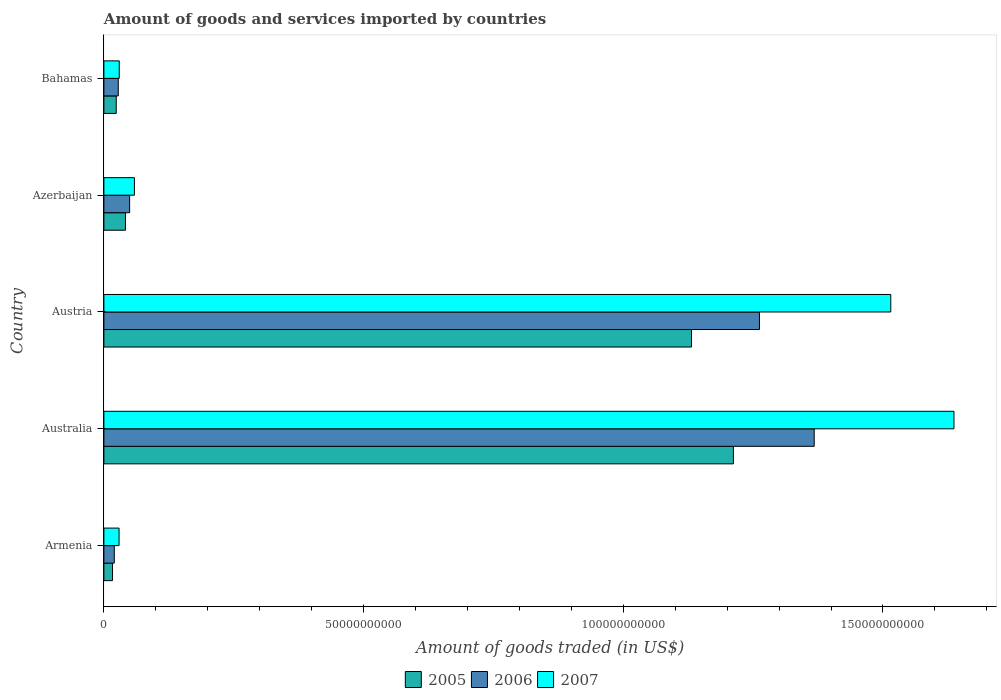How many different coloured bars are there?
Your answer should be compact. 3. Are the number of bars per tick equal to the number of legend labels?
Your response must be concise. Yes. What is the label of the 5th group of bars from the top?
Provide a short and direct response. Armenia. What is the total amount of goods and services imported in 2005 in Austria?
Ensure brevity in your answer.  1.13e+11. Across all countries, what is the maximum total amount of goods and services imported in 2005?
Your response must be concise. 1.21e+11. Across all countries, what is the minimum total amount of goods and services imported in 2005?
Your response must be concise. 1.66e+09. In which country was the total amount of goods and services imported in 2006 maximum?
Your answer should be compact. Australia. In which country was the total amount of goods and services imported in 2007 minimum?
Your answer should be compact. Armenia. What is the total total amount of goods and services imported in 2006 in the graph?
Offer a very short reply. 2.73e+11. What is the difference between the total amount of goods and services imported in 2005 in Australia and that in Azerbaijan?
Offer a terse response. 1.17e+11. What is the difference between the total amount of goods and services imported in 2005 in Bahamas and the total amount of goods and services imported in 2006 in Azerbaijan?
Your answer should be very brief. -2.58e+09. What is the average total amount of goods and services imported in 2005 per country?
Make the answer very short. 4.85e+1. What is the difference between the total amount of goods and services imported in 2005 and total amount of goods and services imported in 2007 in Australia?
Ensure brevity in your answer.  -4.25e+1. In how many countries, is the total amount of goods and services imported in 2007 greater than 110000000000 US$?
Offer a terse response. 2. What is the ratio of the total amount of goods and services imported in 2005 in Armenia to that in Austria?
Offer a terse response. 0.01. Is the difference between the total amount of goods and services imported in 2005 in Armenia and Australia greater than the difference between the total amount of goods and services imported in 2007 in Armenia and Australia?
Offer a terse response. Yes. What is the difference between the highest and the second highest total amount of goods and services imported in 2005?
Ensure brevity in your answer.  8.06e+09. What is the difference between the highest and the lowest total amount of goods and services imported in 2005?
Keep it short and to the point. 1.20e+11. In how many countries, is the total amount of goods and services imported in 2006 greater than the average total amount of goods and services imported in 2006 taken over all countries?
Give a very brief answer. 2. Is the sum of the total amount of goods and services imported in 2006 in Armenia and Australia greater than the maximum total amount of goods and services imported in 2007 across all countries?
Ensure brevity in your answer.  No. What does the 1st bar from the top in Bahamas represents?
Offer a very short reply. 2007. Is it the case that in every country, the sum of the total amount of goods and services imported in 2005 and total amount of goods and services imported in 2006 is greater than the total amount of goods and services imported in 2007?
Offer a terse response. Yes. How many bars are there?
Your response must be concise. 15. Are all the bars in the graph horizontal?
Ensure brevity in your answer.  Yes. What is the difference between two consecutive major ticks on the X-axis?
Offer a terse response. 5.00e+1. Are the values on the major ticks of X-axis written in scientific E-notation?
Provide a succinct answer. No. How are the legend labels stacked?
Give a very brief answer. Horizontal. What is the title of the graph?
Provide a succinct answer. Amount of goods and services imported by countries. Does "1999" appear as one of the legend labels in the graph?
Keep it short and to the point. No. What is the label or title of the X-axis?
Your response must be concise. Amount of goods traded (in US$). What is the label or title of the Y-axis?
Your answer should be compact. Country. What is the Amount of goods traded (in US$) of 2005 in Armenia?
Ensure brevity in your answer.  1.66e+09. What is the Amount of goods traded (in US$) in 2006 in Armenia?
Offer a terse response. 2.00e+09. What is the Amount of goods traded (in US$) in 2007 in Armenia?
Provide a succinct answer. 2.92e+09. What is the Amount of goods traded (in US$) in 2005 in Australia?
Give a very brief answer. 1.21e+11. What is the Amount of goods traded (in US$) of 2006 in Australia?
Offer a terse response. 1.37e+11. What is the Amount of goods traded (in US$) of 2007 in Australia?
Provide a succinct answer. 1.64e+11. What is the Amount of goods traded (in US$) of 2005 in Austria?
Provide a succinct answer. 1.13e+11. What is the Amount of goods traded (in US$) of 2006 in Austria?
Offer a terse response. 1.26e+11. What is the Amount of goods traded (in US$) of 2007 in Austria?
Give a very brief answer. 1.52e+11. What is the Amount of goods traded (in US$) of 2005 in Azerbaijan?
Ensure brevity in your answer.  4.15e+09. What is the Amount of goods traded (in US$) in 2006 in Azerbaijan?
Your answer should be very brief. 4.95e+09. What is the Amount of goods traded (in US$) in 2007 in Azerbaijan?
Provide a succinct answer. 5.88e+09. What is the Amount of goods traded (in US$) of 2005 in Bahamas?
Give a very brief answer. 2.38e+09. What is the Amount of goods traded (in US$) of 2006 in Bahamas?
Your answer should be compact. 2.77e+09. What is the Amount of goods traded (in US$) of 2007 in Bahamas?
Provide a short and direct response. 2.96e+09. Across all countries, what is the maximum Amount of goods traded (in US$) in 2005?
Offer a terse response. 1.21e+11. Across all countries, what is the maximum Amount of goods traded (in US$) of 2006?
Provide a succinct answer. 1.37e+11. Across all countries, what is the maximum Amount of goods traded (in US$) of 2007?
Your answer should be very brief. 1.64e+11. Across all countries, what is the minimum Amount of goods traded (in US$) of 2005?
Your answer should be compact. 1.66e+09. Across all countries, what is the minimum Amount of goods traded (in US$) of 2006?
Your response must be concise. 2.00e+09. Across all countries, what is the minimum Amount of goods traded (in US$) of 2007?
Offer a very short reply. 2.92e+09. What is the total Amount of goods traded (in US$) in 2005 in the graph?
Your answer should be compact. 2.43e+11. What is the total Amount of goods traded (in US$) of 2006 in the graph?
Give a very brief answer. 2.73e+11. What is the total Amount of goods traded (in US$) of 2007 in the graph?
Ensure brevity in your answer.  3.27e+11. What is the difference between the Amount of goods traded (in US$) in 2005 in Armenia and that in Australia?
Your answer should be compact. -1.20e+11. What is the difference between the Amount of goods traded (in US$) of 2006 in Armenia and that in Australia?
Offer a very short reply. -1.35e+11. What is the difference between the Amount of goods traded (in US$) of 2007 in Armenia and that in Australia?
Provide a succinct answer. -1.61e+11. What is the difference between the Amount of goods traded (in US$) in 2005 in Armenia and that in Austria?
Your response must be concise. -1.11e+11. What is the difference between the Amount of goods traded (in US$) of 2006 in Armenia and that in Austria?
Your answer should be very brief. -1.24e+11. What is the difference between the Amount of goods traded (in US$) of 2007 in Armenia and that in Austria?
Keep it short and to the point. -1.49e+11. What is the difference between the Amount of goods traded (in US$) of 2005 in Armenia and that in Azerbaijan?
Provide a short and direct response. -2.49e+09. What is the difference between the Amount of goods traded (in US$) in 2006 in Armenia and that in Azerbaijan?
Ensure brevity in your answer.  -2.95e+09. What is the difference between the Amount of goods traded (in US$) in 2007 in Armenia and that in Azerbaijan?
Your answer should be compact. -2.96e+09. What is the difference between the Amount of goods traded (in US$) in 2005 in Armenia and that in Bahamas?
Your answer should be compact. -7.14e+08. What is the difference between the Amount of goods traded (in US$) in 2006 in Armenia and that in Bahamas?
Make the answer very short. -7.67e+08. What is the difference between the Amount of goods traded (in US$) in 2007 in Armenia and that in Bahamas?
Your answer should be very brief. -3.58e+07. What is the difference between the Amount of goods traded (in US$) in 2005 in Australia and that in Austria?
Provide a short and direct response. 8.06e+09. What is the difference between the Amount of goods traded (in US$) in 2006 in Australia and that in Austria?
Your answer should be compact. 1.05e+1. What is the difference between the Amount of goods traded (in US$) in 2007 in Australia and that in Austria?
Your answer should be very brief. 1.22e+1. What is the difference between the Amount of goods traded (in US$) in 2005 in Australia and that in Azerbaijan?
Your answer should be very brief. 1.17e+11. What is the difference between the Amount of goods traded (in US$) of 2006 in Australia and that in Azerbaijan?
Offer a terse response. 1.32e+11. What is the difference between the Amount of goods traded (in US$) in 2007 in Australia and that in Azerbaijan?
Offer a terse response. 1.58e+11. What is the difference between the Amount of goods traded (in US$) of 2005 in Australia and that in Bahamas?
Make the answer very short. 1.19e+11. What is the difference between the Amount of goods traded (in US$) in 2006 in Australia and that in Bahamas?
Offer a very short reply. 1.34e+11. What is the difference between the Amount of goods traded (in US$) of 2007 in Australia and that in Bahamas?
Your answer should be very brief. 1.61e+11. What is the difference between the Amount of goods traded (in US$) of 2005 in Austria and that in Azerbaijan?
Provide a short and direct response. 1.09e+11. What is the difference between the Amount of goods traded (in US$) in 2006 in Austria and that in Azerbaijan?
Ensure brevity in your answer.  1.21e+11. What is the difference between the Amount of goods traded (in US$) of 2007 in Austria and that in Azerbaijan?
Your answer should be very brief. 1.46e+11. What is the difference between the Amount of goods traded (in US$) of 2005 in Austria and that in Bahamas?
Offer a very short reply. 1.11e+11. What is the difference between the Amount of goods traded (in US$) of 2006 in Austria and that in Bahamas?
Your response must be concise. 1.23e+11. What is the difference between the Amount of goods traded (in US$) of 2007 in Austria and that in Bahamas?
Offer a terse response. 1.49e+11. What is the difference between the Amount of goods traded (in US$) of 2005 in Azerbaijan and that in Bahamas?
Ensure brevity in your answer.  1.77e+09. What is the difference between the Amount of goods traded (in US$) of 2006 in Azerbaijan and that in Bahamas?
Provide a succinct answer. 2.19e+09. What is the difference between the Amount of goods traded (in US$) of 2007 in Azerbaijan and that in Bahamas?
Make the answer very short. 2.92e+09. What is the difference between the Amount of goods traded (in US$) in 2005 in Armenia and the Amount of goods traded (in US$) in 2006 in Australia?
Make the answer very short. -1.35e+11. What is the difference between the Amount of goods traded (in US$) in 2005 in Armenia and the Amount of goods traded (in US$) in 2007 in Australia?
Your answer should be very brief. -1.62e+11. What is the difference between the Amount of goods traded (in US$) in 2006 in Armenia and the Amount of goods traded (in US$) in 2007 in Australia?
Your answer should be very brief. -1.62e+11. What is the difference between the Amount of goods traded (in US$) of 2005 in Armenia and the Amount of goods traded (in US$) of 2006 in Austria?
Your answer should be very brief. -1.25e+11. What is the difference between the Amount of goods traded (in US$) of 2005 in Armenia and the Amount of goods traded (in US$) of 2007 in Austria?
Ensure brevity in your answer.  -1.50e+11. What is the difference between the Amount of goods traded (in US$) in 2006 in Armenia and the Amount of goods traded (in US$) in 2007 in Austria?
Offer a very short reply. -1.50e+11. What is the difference between the Amount of goods traded (in US$) of 2005 in Armenia and the Amount of goods traded (in US$) of 2006 in Azerbaijan?
Give a very brief answer. -3.29e+09. What is the difference between the Amount of goods traded (in US$) in 2005 in Armenia and the Amount of goods traded (in US$) in 2007 in Azerbaijan?
Your response must be concise. -4.21e+09. What is the difference between the Amount of goods traded (in US$) in 2006 in Armenia and the Amount of goods traded (in US$) in 2007 in Azerbaijan?
Your answer should be compact. -3.88e+09. What is the difference between the Amount of goods traded (in US$) in 2005 in Armenia and the Amount of goods traded (in US$) in 2006 in Bahamas?
Ensure brevity in your answer.  -1.10e+09. What is the difference between the Amount of goods traded (in US$) of 2005 in Armenia and the Amount of goods traded (in US$) of 2007 in Bahamas?
Keep it short and to the point. -1.29e+09. What is the difference between the Amount of goods traded (in US$) of 2006 in Armenia and the Amount of goods traded (in US$) of 2007 in Bahamas?
Keep it short and to the point. -9.57e+08. What is the difference between the Amount of goods traded (in US$) in 2005 in Australia and the Amount of goods traded (in US$) in 2006 in Austria?
Keep it short and to the point. -5.01e+09. What is the difference between the Amount of goods traded (in US$) of 2005 in Australia and the Amount of goods traded (in US$) of 2007 in Austria?
Give a very brief answer. -3.03e+1. What is the difference between the Amount of goods traded (in US$) of 2006 in Australia and the Amount of goods traded (in US$) of 2007 in Austria?
Your answer should be compact. -1.47e+1. What is the difference between the Amount of goods traded (in US$) in 2005 in Australia and the Amount of goods traded (in US$) in 2006 in Azerbaijan?
Offer a very short reply. 1.16e+11. What is the difference between the Amount of goods traded (in US$) of 2005 in Australia and the Amount of goods traded (in US$) of 2007 in Azerbaijan?
Your answer should be very brief. 1.15e+11. What is the difference between the Amount of goods traded (in US$) in 2006 in Australia and the Amount of goods traded (in US$) in 2007 in Azerbaijan?
Provide a succinct answer. 1.31e+11. What is the difference between the Amount of goods traded (in US$) in 2005 in Australia and the Amount of goods traded (in US$) in 2006 in Bahamas?
Your answer should be compact. 1.18e+11. What is the difference between the Amount of goods traded (in US$) in 2005 in Australia and the Amount of goods traded (in US$) in 2007 in Bahamas?
Your answer should be compact. 1.18e+11. What is the difference between the Amount of goods traded (in US$) of 2006 in Australia and the Amount of goods traded (in US$) of 2007 in Bahamas?
Keep it short and to the point. 1.34e+11. What is the difference between the Amount of goods traded (in US$) of 2005 in Austria and the Amount of goods traded (in US$) of 2006 in Azerbaijan?
Your answer should be very brief. 1.08e+11. What is the difference between the Amount of goods traded (in US$) of 2005 in Austria and the Amount of goods traded (in US$) of 2007 in Azerbaijan?
Offer a very short reply. 1.07e+11. What is the difference between the Amount of goods traded (in US$) of 2006 in Austria and the Amount of goods traded (in US$) of 2007 in Azerbaijan?
Give a very brief answer. 1.20e+11. What is the difference between the Amount of goods traded (in US$) of 2005 in Austria and the Amount of goods traded (in US$) of 2006 in Bahamas?
Make the answer very short. 1.10e+11. What is the difference between the Amount of goods traded (in US$) in 2005 in Austria and the Amount of goods traded (in US$) in 2007 in Bahamas?
Keep it short and to the point. 1.10e+11. What is the difference between the Amount of goods traded (in US$) of 2006 in Austria and the Amount of goods traded (in US$) of 2007 in Bahamas?
Make the answer very short. 1.23e+11. What is the difference between the Amount of goods traded (in US$) of 2005 in Azerbaijan and the Amount of goods traded (in US$) of 2006 in Bahamas?
Offer a terse response. 1.39e+09. What is the difference between the Amount of goods traded (in US$) of 2005 in Azerbaijan and the Amount of goods traded (in US$) of 2007 in Bahamas?
Your answer should be very brief. 1.19e+09. What is the difference between the Amount of goods traded (in US$) of 2006 in Azerbaijan and the Amount of goods traded (in US$) of 2007 in Bahamas?
Keep it short and to the point. 2.00e+09. What is the average Amount of goods traded (in US$) in 2005 per country?
Your answer should be very brief. 4.85e+1. What is the average Amount of goods traded (in US$) in 2006 per country?
Keep it short and to the point. 5.45e+1. What is the average Amount of goods traded (in US$) in 2007 per country?
Provide a succinct answer. 6.54e+1. What is the difference between the Amount of goods traded (in US$) of 2005 and Amount of goods traded (in US$) of 2006 in Armenia?
Provide a succinct answer. -3.37e+08. What is the difference between the Amount of goods traded (in US$) of 2005 and Amount of goods traded (in US$) of 2007 in Armenia?
Keep it short and to the point. -1.26e+09. What is the difference between the Amount of goods traded (in US$) of 2006 and Amount of goods traded (in US$) of 2007 in Armenia?
Give a very brief answer. -9.21e+08. What is the difference between the Amount of goods traded (in US$) of 2005 and Amount of goods traded (in US$) of 2006 in Australia?
Your answer should be compact. -1.56e+1. What is the difference between the Amount of goods traded (in US$) in 2005 and Amount of goods traded (in US$) in 2007 in Australia?
Provide a succinct answer. -4.25e+1. What is the difference between the Amount of goods traded (in US$) of 2006 and Amount of goods traded (in US$) of 2007 in Australia?
Make the answer very short. -2.69e+1. What is the difference between the Amount of goods traded (in US$) in 2005 and Amount of goods traded (in US$) in 2006 in Austria?
Your response must be concise. -1.31e+1. What is the difference between the Amount of goods traded (in US$) of 2005 and Amount of goods traded (in US$) of 2007 in Austria?
Keep it short and to the point. -3.84e+1. What is the difference between the Amount of goods traded (in US$) of 2006 and Amount of goods traded (in US$) of 2007 in Austria?
Give a very brief answer. -2.53e+1. What is the difference between the Amount of goods traded (in US$) in 2005 and Amount of goods traded (in US$) in 2006 in Azerbaijan?
Your response must be concise. -8.02e+08. What is the difference between the Amount of goods traded (in US$) of 2005 and Amount of goods traded (in US$) of 2007 in Azerbaijan?
Ensure brevity in your answer.  -1.73e+09. What is the difference between the Amount of goods traded (in US$) in 2006 and Amount of goods traded (in US$) in 2007 in Azerbaijan?
Offer a terse response. -9.23e+08. What is the difference between the Amount of goods traded (in US$) of 2005 and Amount of goods traded (in US$) of 2006 in Bahamas?
Ensure brevity in your answer.  -3.89e+08. What is the difference between the Amount of goods traded (in US$) in 2005 and Amount of goods traded (in US$) in 2007 in Bahamas?
Offer a terse response. -5.79e+08. What is the difference between the Amount of goods traded (in US$) in 2006 and Amount of goods traded (in US$) in 2007 in Bahamas?
Make the answer very short. -1.90e+08. What is the ratio of the Amount of goods traded (in US$) in 2005 in Armenia to that in Australia?
Your answer should be compact. 0.01. What is the ratio of the Amount of goods traded (in US$) of 2006 in Armenia to that in Australia?
Keep it short and to the point. 0.01. What is the ratio of the Amount of goods traded (in US$) in 2007 in Armenia to that in Australia?
Offer a very short reply. 0.02. What is the ratio of the Amount of goods traded (in US$) of 2005 in Armenia to that in Austria?
Your response must be concise. 0.01. What is the ratio of the Amount of goods traded (in US$) in 2006 in Armenia to that in Austria?
Offer a terse response. 0.02. What is the ratio of the Amount of goods traded (in US$) of 2007 in Armenia to that in Austria?
Make the answer very short. 0.02. What is the ratio of the Amount of goods traded (in US$) of 2005 in Armenia to that in Azerbaijan?
Provide a succinct answer. 0.4. What is the ratio of the Amount of goods traded (in US$) of 2006 in Armenia to that in Azerbaijan?
Keep it short and to the point. 0.4. What is the ratio of the Amount of goods traded (in US$) of 2007 in Armenia to that in Azerbaijan?
Provide a short and direct response. 0.5. What is the ratio of the Amount of goods traded (in US$) of 2005 in Armenia to that in Bahamas?
Give a very brief answer. 0.7. What is the ratio of the Amount of goods traded (in US$) in 2006 in Armenia to that in Bahamas?
Provide a succinct answer. 0.72. What is the ratio of the Amount of goods traded (in US$) of 2007 in Armenia to that in Bahamas?
Your response must be concise. 0.99. What is the ratio of the Amount of goods traded (in US$) of 2005 in Australia to that in Austria?
Ensure brevity in your answer.  1.07. What is the ratio of the Amount of goods traded (in US$) of 2006 in Australia to that in Austria?
Make the answer very short. 1.08. What is the ratio of the Amount of goods traded (in US$) in 2007 in Australia to that in Austria?
Offer a terse response. 1.08. What is the ratio of the Amount of goods traded (in US$) in 2005 in Australia to that in Azerbaijan?
Make the answer very short. 29.19. What is the ratio of the Amount of goods traded (in US$) of 2006 in Australia to that in Azerbaijan?
Your response must be concise. 27.61. What is the ratio of the Amount of goods traded (in US$) of 2007 in Australia to that in Azerbaijan?
Your answer should be very brief. 27.85. What is the ratio of the Amount of goods traded (in US$) of 2005 in Australia to that in Bahamas?
Make the answer very short. 50.98. What is the ratio of the Amount of goods traded (in US$) in 2006 in Australia to that in Bahamas?
Your answer should be very brief. 49.43. What is the ratio of the Amount of goods traded (in US$) in 2007 in Australia to that in Bahamas?
Give a very brief answer. 55.35. What is the ratio of the Amount of goods traded (in US$) of 2005 in Austria to that in Azerbaijan?
Provide a succinct answer. 27.25. What is the ratio of the Amount of goods traded (in US$) in 2006 in Austria to that in Azerbaijan?
Make the answer very short. 25.48. What is the ratio of the Amount of goods traded (in US$) of 2007 in Austria to that in Azerbaijan?
Your answer should be compact. 25.78. What is the ratio of the Amount of goods traded (in US$) in 2005 in Austria to that in Bahamas?
Offer a very short reply. 47.59. What is the ratio of the Amount of goods traded (in US$) in 2006 in Austria to that in Bahamas?
Your response must be concise. 45.62. What is the ratio of the Amount of goods traded (in US$) in 2007 in Austria to that in Bahamas?
Keep it short and to the point. 51.24. What is the ratio of the Amount of goods traded (in US$) of 2005 in Azerbaijan to that in Bahamas?
Ensure brevity in your answer.  1.75. What is the ratio of the Amount of goods traded (in US$) of 2006 in Azerbaijan to that in Bahamas?
Offer a very short reply. 1.79. What is the ratio of the Amount of goods traded (in US$) of 2007 in Azerbaijan to that in Bahamas?
Your answer should be compact. 1.99. What is the difference between the highest and the second highest Amount of goods traded (in US$) of 2005?
Offer a terse response. 8.06e+09. What is the difference between the highest and the second highest Amount of goods traded (in US$) of 2006?
Provide a short and direct response. 1.05e+1. What is the difference between the highest and the second highest Amount of goods traded (in US$) of 2007?
Offer a terse response. 1.22e+1. What is the difference between the highest and the lowest Amount of goods traded (in US$) of 2005?
Your answer should be compact. 1.20e+11. What is the difference between the highest and the lowest Amount of goods traded (in US$) in 2006?
Keep it short and to the point. 1.35e+11. What is the difference between the highest and the lowest Amount of goods traded (in US$) of 2007?
Make the answer very short. 1.61e+11. 